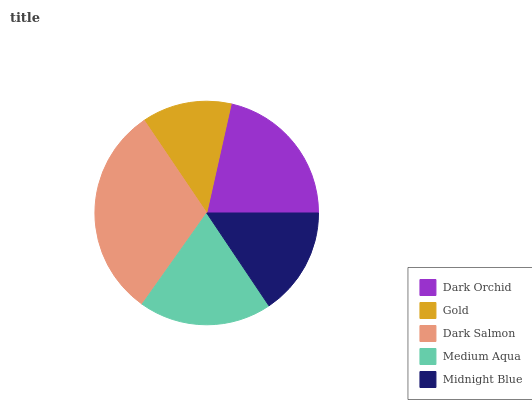Is Gold the minimum?
Answer yes or no. Yes. Is Dark Salmon the maximum?
Answer yes or no. Yes. Is Dark Salmon the minimum?
Answer yes or no. No. Is Gold the maximum?
Answer yes or no. No. Is Dark Salmon greater than Gold?
Answer yes or no. Yes. Is Gold less than Dark Salmon?
Answer yes or no. Yes. Is Gold greater than Dark Salmon?
Answer yes or no. No. Is Dark Salmon less than Gold?
Answer yes or no. No. Is Medium Aqua the high median?
Answer yes or no. Yes. Is Medium Aqua the low median?
Answer yes or no. Yes. Is Gold the high median?
Answer yes or no. No. Is Gold the low median?
Answer yes or no. No. 